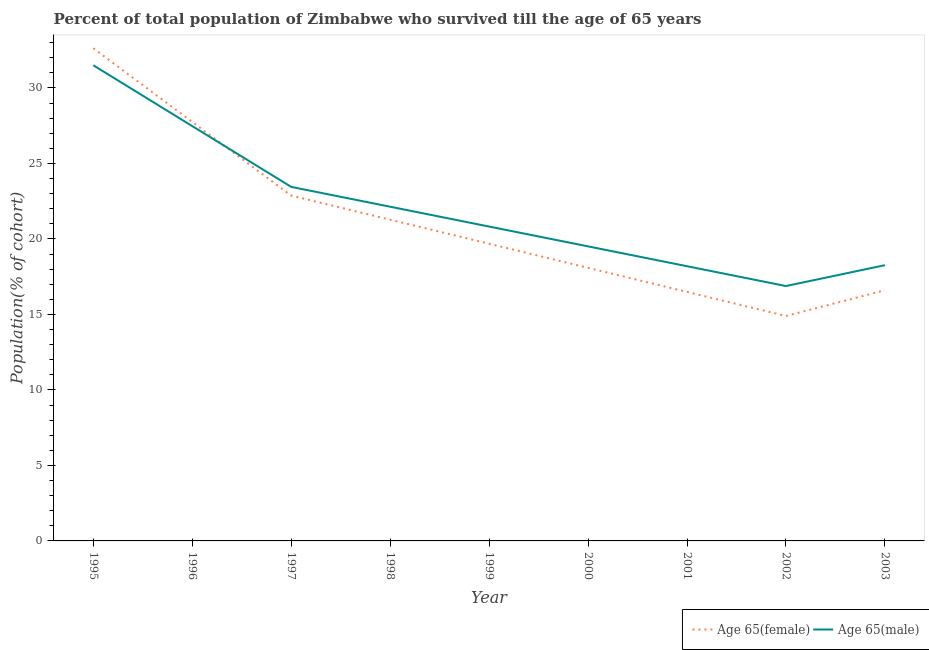How many different coloured lines are there?
Keep it short and to the point. 2. Does the line corresponding to percentage of female population who survived till age of 65 intersect with the line corresponding to percentage of male population who survived till age of 65?
Offer a very short reply. Yes. What is the percentage of female population who survived till age of 65 in 2002?
Your response must be concise. 14.9. Across all years, what is the maximum percentage of male population who survived till age of 65?
Offer a very short reply. 31.5. Across all years, what is the minimum percentage of male population who survived till age of 65?
Ensure brevity in your answer.  16.88. In which year was the percentage of female population who survived till age of 65 maximum?
Keep it short and to the point. 1995. In which year was the percentage of female population who survived till age of 65 minimum?
Your answer should be compact. 2002. What is the total percentage of male population who survived till age of 65 in the graph?
Provide a short and direct response. 198.22. What is the difference between the percentage of male population who survived till age of 65 in 1998 and that in 2001?
Offer a terse response. 3.94. What is the difference between the percentage of male population who survived till age of 65 in 1997 and the percentage of female population who survived till age of 65 in 1998?
Your response must be concise. 2.17. What is the average percentage of male population who survived till age of 65 per year?
Make the answer very short. 22.02. In the year 1998, what is the difference between the percentage of female population who survived till age of 65 and percentage of male population who survived till age of 65?
Your answer should be very brief. -0.86. What is the ratio of the percentage of female population who survived till age of 65 in 1996 to that in 2003?
Your response must be concise. 1.67. Is the percentage of male population who survived till age of 65 in 1995 less than that in 2000?
Offer a very short reply. No. Is the difference between the percentage of female population who survived till age of 65 in 1995 and 1997 greater than the difference between the percentage of male population who survived till age of 65 in 1995 and 1997?
Make the answer very short. Yes. What is the difference between the highest and the second highest percentage of female population who survived till age of 65?
Keep it short and to the point. 4.88. What is the difference between the highest and the lowest percentage of female population who survived till age of 65?
Give a very brief answer. 17.73. What is the difference between two consecutive major ticks on the Y-axis?
Provide a succinct answer. 5. Are the values on the major ticks of Y-axis written in scientific E-notation?
Offer a very short reply. No. Does the graph contain any zero values?
Provide a short and direct response. No. How many legend labels are there?
Give a very brief answer. 2. How are the legend labels stacked?
Your answer should be compact. Horizontal. What is the title of the graph?
Make the answer very short. Percent of total population of Zimbabwe who survived till the age of 65 years. What is the label or title of the Y-axis?
Provide a short and direct response. Population(% of cohort). What is the Population(% of cohort) of Age 65(female) in 1995?
Ensure brevity in your answer.  32.63. What is the Population(% of cohort) in Age 65(male) in 1995?
Provide a short and direct response. 31.5. What is the Population(% of cohort) of Age 65(female) in 1996?
Your response must be concise. 27.75. What is the Population(% of cohort) in Age 65(male) in 1996?
Ensure brevity in your answer.  27.47. What is the Population(% of cohort) in Age 65(female) in 1997?
Keep it short and to the point. 22.87. What is the Population(% of cohort) of Age 65(male) in 1997?
Offer a very short reply. 23.45. What is the Population(% of cohort) in Age 65(female) in 1998?
Provide a short and direct response. 21.28. What is the Population(% of cohort) of Age 65(male) in 1998?
Offer a terse response. 22.13. What is the Population(% of cohort) of Age 65(female) in 1999?
Provide a succinct answer. 19.68. What is the Population(% of cohort) of Age 65(male) in 1999?
Your answer should be very brief. 20.82. What is the Population(% of cohort) of Age 65(female) in 2000?
Give a very brief answer. 18.09. What is the Population(% of cohort) of Age 65(male) in 2000?
Your answer should be compact. 19.51. What is the Population(% of cohort) of Age 65(female) in 2001?
Make the answer very short. 16.49. What is the Population(% of cohort) of Age 65(male) in 2001?
Ensure brevity in your answer.  18.19. What is the Population(% of cohort) of Age 65(female) in 2002?
Your response must be concise. 14.9. What is the Population(% of cohort) in Age 65(male) in 2002?
Ensure brevity in your answer.  16.88. What is the Population(% of cohort) of Age 65(female) in 2003?
Offer a very short reply. 16.6. What is the Population(% of cohort) in Age 65(male) in 2003?
Make the answer very short. 18.26. Across all years, what is the maximum Population(% of cohort) in Age 65(female)?
Keep it short and to the point. 32.63. Across all years, what is the maximum Population(% of cohort) of Age 65(male)?
Provide a short and direct response. 31.5. Across all years, what is the minimum Population(% of cohort) of Age 65(female)?
Your response must be concise. 14.9. Across all years, what is the minimum Population(% of cohort) of Age 65(male)?
Your response must be concise. 16.88. What is the total Population(% of cohort) in Age 65(female) in the graph?
Your answer should be compact. 190.28. What is the total Population(% of cohort) in Age 65(male) in the graph?
Your answer should be very brief. 198.22. What is the difference between the Population(% of cohort) of Age 65(female) in 1995 and that in 1996?
Offer a very short reply. 4.88. What is the difference between the Population(% of cohort) in Age 65(male) in 1995 and that in 1996?
Make the answer very short. 4.03. What is the difference between the Population(% of cohort) of Age 65(female) in 1995 and that in 1997?
Your answer should be very brief. 9.76. What is the difference between the Population(% of cohort) in Age 65(male) in 1995 and that in 1997?
Make the answer very short. 8.05. What is the difference between the Population(% of cohort) in Age 65(female) in 1995 and that in 1998?
Give a very brief answer. 11.35. What is the difference between the Population(% of cohort) in Age 65(male) in 1995 and that in 1998?
Give a very brief answer. 9.37. What is the difference between the Population(% of cohort) of Age 65(female) in 1995 and that in 1999?
Offer a very short reply. 12.95. What is the difference between the Population(% of cohort) in Age 65(male) in 1995 and that in 1999?
Make the answer very short. 10.68. What is the difference between the Population(% of cohort) in Age 65(female) in 1995 and that in 2000?
Offer a terse response. 14.54. What is the difference between the Population(% of cohort) of Age 65(male) in 1995 and that in 2000?
Your answer should be compact. 11.99. What is the difference between the Population(% of cohort) of Age 65(female) in 1995 and that in 2001?
Provide a short and direct response. 16.14. What is the difference between the Population(% of cohort) of Age 65(male) in 1995 and that in 2001?
Provide a succinct answer. 13.31. What is the difference between the Population(% of cohort) of Age 65(female) in 1995 and that in 2002?
Offer a terse response. 17.73. What is the difference between the Population(% of cohort) of Age 65(male) in 1995 and that in 2002?
Provide a short and direct response. 14.62. What is the difference between the Population(% of cohort) of Age 65(female) in 1995 and that in 2003?
Give a very brief answer. 16.03. What is the difference between the Population(% of cohort) of Age 65(male) in 1995 and that in 2003?
Give a very brief answer. 13.24. What is the difference between the Population(% of cohort) in Age 65(female) in 1996 and that in 1997?
Give a very brief answer. 4.88. What is the difference between the Population(% of cohort) of Age 65(male) in 1996 and that in 1997?
Keep it short and to the point. 4.03. What is the difference between the Population(% of cohort) of Age 65(female) in 1996 and that in 1998?
Your answer should be very brief. 6.47. What is the difference between the Population(% of cohort) of Age 65(male) in 1996 and that in 1998?
Your answer should be compact. 5.34. What is the difference between the Population(% of cohort) of Age 65(female) in 1996 and that in 1999?
Provide a succinct answer. 8.07. What is the difference between the Population(% of cohort) in Age 65(male) in 1996 and that in 1999?
Ensure brevity in your answer.  6.65. What is the difference between the Population(% of cohort) in Age 65(female) in 1996 and that in 2000?
Provide a succinct answer. 9.66. What is the difference between the Population(% of cohort) of Age 65(male) in 1996 and that in 2000?
Offer a terse response. 7.97. What is the difference between the Population(% of cohort) in Age 65(female) in 1996 and that in 2001?
Keep it short and to the point. 11.26. What is the difference between the Population(% of cohort) in Age 65(male) in 1996 and that in 2001?
Give a very brief answer. 9.28. What is the difference between the Population(% of cohort) in Age 65(female) in 1996 and that in 2002?
Offer a very short reply. 12.85. What is the difference between the Population(% of cohort) in Age 65(male) in 1996 and that in 2002?
Give a very brief answer. 10.59. What is the difference between the Population(% of cohort) of Age 65(female) in 1996 and that in 2003?
Offer a terse response. 11.15. What is the difference between the Population(% of cohort) in Age 65(male) in 1996 and that in 2003?
Your answer should be very brief. 9.21. What is the difference between the Population(% of cohort) in Age 65(female) in 1997 and that in 1998?
Your response must be concise. 1.59. What is the difference between the Population(% of cohort) of Age 65(male) in 1997 and that in 1998?
Your answer should be compact. 1.31. What is the difference between the Population(% of cohort) in Age 65(female) in 1997 and that in 1999?
Keep it short and to the point. 3.19. What is the difference between the Population(% of cohort) in Age 65(male) in 1997 and that in 1999?
Offer a terse response. 2.63. What is the difference between the Population(% of cohort) in Age 65(female) in 1997 and that in 2000?
Your response must be concise. 4.78. What is the difference between the Population(% of cohort) in Age 65(male) in 1997 and that in 2000?
Make the answer very short. 3.94. What is the difference between the Population(% of cohort) in Age 65(female) in 1997 and that in 2001?
Offer a very short reply. 6.38. What is the difference between the Population(% of cohort) of Age 65(male) in 1997 and that in 2001?
Provide a short and direct response. 5.25. What is the difference between the Population(% of cohort) in Age 65(female) in 1997 and that in 2002?
Ensure brevity in your answer.  7.97. What is the difference between the Population(% of cohort) of Age 65(male) in 1997 and that in 2002?
Your answer should be compact. 6.57. What is the difference between the Population(% of cohort) of Age 65(female) in 1997 and that in 2003?
Offer a very short reply. 6.27. What is the difference between the Population(% of cohort) of Age 65(male) in 1997 and that in 2003?
Offer a terse response. 5.19. What is the difference between the Population(% of cohort) in Age 65(female) in 1998 and that in 1999?
Make the answer very short. 1.59. What is the difference between the Population(% of cohort) in Age 65(male) in 1998 and that in 1999?
Keep it short and to the point. 1.31. What is the difference between the Population(% of cohort) of Age 65(female) in 1998 and that in 2000?
Keep it short and to the point. 3.19. What is the difference between the Population(% of cohort) in Age 65(male) in 1998 and that in 2000?
Your answer should be compact. 2.63. What is the difference between the Population(% of cohort) in Age 65(female) in 1998 and that in 2001?
Provide a succinct answer. 4.78. What is the difference between the Population(% of cohort) of Age 65(male) in 1998 and that in 2001?
Provide a short and direct response. 3.94. What is the difference between the Population(% of cohort) in Age 65(female) in 1998 and that in 2002?
Give a very brief answer. 6.38. What is the difference between the Population(% of cohort) of Age 65(male) in 1998 and that in 2002?
Your answer should be very brief. 5.25. What is the difference between the Population(% of cohort) in Age 65(female) in 1998 and that in 2003?
Provide a short and direct response. 4.67. What is the difference between the Population(% of cohort) of Age 65(male) in 1998 and that in 2003?
Give a very brief answer. 3.87. What is the difference between the Population(% of cohort) in Age 65(female) in 1999 and that in 2000?
Make the answer very short. 1.59. What is the difference between the Population(% of cohort) in Age 65(male) in 1999 and that in 2000?
Provide a short and direct response. 1.31. What is the difference between the Population(% of cohort) of Age 65(female) in 1999 and that in 2001?
Offer a terse response. 3.19. What is the difference between the Population(% of cohort) in Age 65(male) in 1999 and that in 2001?
Ensure brevity in your answer.  2.63. What is the difference between the Population(% of cohort) of Age 65(female) in 1999 and that in 2002?
Offer a very short reply. 4.78. What is the difference between the Population(% of cohort) in Age 65(male) in 1999 and that in 2002?
Your answer should be compact. 3.94. What is the difference between the Population(% of cohort) of Age 65(female) in 1999 and that in 2003?
Your answer should be very brief. 3.08. What is the difference between the Population(% of cohort) of Age 65(male) in 1999 and that in 2003?
Provide a succinct answer. 2.56. What is the difference between the Population(% of cohort) in Age 65(female) in 2000 and that in 2001?
Provide a short and direct response. 1.59. What is the difference between the Population(% of cohort) of Age 65(male) in 2000 and that in 2001?
Your response must be concise. 1.31. What is the difference between the Population(% of cohort) in Age 65(female) in 2000 and that in 2002?
Your answer should be compact. 3.19. What is the difference between the Population(% of cohort) in Age 65(male) in 2000 and that in 2002?
Provide a short and direct response. 2.63. What is the difference between the Population(% of cohort) in Age 65(female) in 2000 and that in 2003?
Give a very brief answer. 1.49. What is the difference between the Population(% of cohort) of Age 65(male) in 2000 and that in 2003?
Provide a succinct answer. 1.25. What is the difference between the Population(% of cohort) in Age 65(female) in 2001 and that in 2002?
Provide a succinct answer. 1.59. What is the difference between the Population(% of cohort) in Age 65(male) in 2001 and that in 2002?
Offer a very short reply. 1.31. What is the difference between the Population(% of cohort) of Age 65(female) in 2001 and that in 2003?
Your answer should be very brief. -0.11. What is the difference between the Population(% of cohort) in Age 65(male) in 2001 and that in 2003?
Your answer should be very brief. -0.07. What is the difference between the Population(% of cohort) of Age 65(female) in 2002 and that in 2003?
Offer a terse response. -1.7. What is the difference between the Population(% of cohort) of Age 65(male) in 2002 and that in 2003?
Ensure brevity in your answer.  -1.38. What is the difference between the Population(% of cohort) of Age 65(female) in 1995 and the Population(% of cohort) of Age 65(male) in 1996?
Provide a succinct answer. 5.15. What is the difference between the Population(% of cohort) of Age 65(female) in 1995 and the Population(% of cohort) of Age 65(male) in 1997?
Your answer should be very brief. 9.18. What is the difference between the Population(% of cohort) of Age 65(female) in 1995 and the Population(% of cohort) of Age 65(male) in 1998?
Your response must be concise. 10.49. What is the difference between the Population(% of cohort) in Age 65(female) in 1995 and the Population(% of cohort) in Age 65(male) in 1999?
Offer a very short reply. 11.81. What is the difference between the Population(% of cohort) in Age 65(female) in 1995 and the Population(% of cohort) in Age 65(male) in 2000?
Give a very brief answer. 13.12. What is the difference between the Population(% of cohort) of Age 65(female) in 1995 and the Population(% of cohort) of Age 65(male) in 2001?
Your answer should be compact. 14.43. What is the difference between the Population(% of cohort) of Age 65(female) in 1995 and the Population(% of cohort) of Age 65(male) in 2002?
Provide a succinct answer. 15.75. What is the difference between the Population(% of cohort) in Age 65(female) in 1995 and the Population(% of cohort) in Age 65(male) in 2003?
Give a very brief answer. 14.37. What is the difference between the Population(% of cohort) in Age 65(female) in 1996 and the Population(% of cohort) in Age 65(male) in 1997?
Give a very brief answer. 4.3. What is the difference between the Population(% of cohort) in Age 65(female) in 1996 and the Population(% of cohort) in Age 65(male) in 1998?
Provide a short and direct response. 5.62. What is the difference between the Population(% of cohort) of Age 65(female) in 1996 and the Population(% of cohort) of Age 65(male) in 1999?
Your response must be concise. 6.93. What is the difference between the Population(% of cohort) of Age 65(female) in 1996 and the Population(% of cohort) of Age 65(male) in 2000?
Your response must be concise. 8.24. What is the difference between the Population(% of cohort) of Age 65(female) in 1996 and the Population(% of cohort) of Age 65(male) in 2001?
Give a very brief answer. 9.56. What is the difference between the Population(% of cohort) of Age 65(female) in 1996 and the Population(% of cohort) of Age 65(male) in 2002?
Offer a terse response. 10.87. What is the difference between the Population(% of cohort) of Age 65(female) in 1996 and the Population(% of cohort) of Age 65(male) in 2003?
Your answer should be compact. 9.49. What is the difference between the Population(% of cohort) in Age 65(female) in 1997 and the Population(% of cohort) in Age 65(male) in 1998?
Offer a very short reply. 0.74. What is the difference between the Population(% of cohort) in Age 65(female) in 1997 and the Population(% of cohort) in Age 65(male) in 1999?
Your response must be concise. 2.05. What is the difference between the Population(% of cohort) of Age 65(female) in 1997 and the Population(% of cohort) of Age 65(male) in 2000?
Provide a succinct answer. 3.36. What is the difference between the Population(% of cohort) of Age 65(female) in 1997 and the Population(% of cohort) of Age 65(male) in 2001?
Your answer should be very brief. 4.68. What is the difference between the Population(% of cohort) in Age 65(female) in 1997 and the Population(% of cohort) in Age 65(male) in 2002?
Offer a very short reply. 5.99. What is the difference between the Population(% of cohort) of Age 65(female) in 1997 and the Population(% of cohort) of Age 65(male) in 2003?
Provide a short and direct response. 4.61. What is the difference between the Population(% of cohort) in Age 65(female) in 1998 and the Population(% of cohort) in Age 65(male) in 1999?
Make the answer very short. 0.46. What is the difference between the Population(% of cohort) in Age 65(female) in 1998 and the Population(% of cohort) in Age 65(male) in 2000?
Your response must be concise. 1.77. What is the difference between the Population(% of cohort) of Age 65(female) in 1998 and the Population(% of cohort) of Age 65(male) in 2001?
Keep it short and to the point. 3.08. What is the difference between the Population(% of cohort) in Age 65(female) in 1998 and the Population(% of cohort) in Age 65(male) in 2002?
Provide a short and direct response. 4.4. What is the difference between the Population(% of cohort) of Age 65(female) in 1998 and the Population(% of cohort) of Age 65(male) in 2003?
Your answer should be compact. 3.01. What is the difference between the Population(% of cohort) in Age 65(female) in 1999 and the Population(% of cohort) in Age 65(male) in 2000?
Provide a succinct answer. 0.17. What is the difference between the Population(% of cohort) in Age 65(female) in 1999 and the Population(% of cohort) in Age 65(male) in 2001?
Your answer should be compact. 1.49. What is the difference between the Population(% of cohort) of Age 65(female) in 1999 and the Population(% of cohort) of Age 65(male) in 2002?
Ensure brevity in your answer.  2.8. What is the difference between the Population(% of cohort) in Age 65(female) in 1999 and the Population(% of cohort) in Age 65(male) in 2003?
Your answer should be compact. 1.42. What is the difference between the Population(% of cohort) of Age 65(female) in 2000 and the Population(% of cohort) of Age 65(male) in 2001?
Offer a terse response. -0.11. What is the difference between the Population(% of cohort) of Age 65(female) in 2000 and the Population(% of cohort) of Age 65(male) in 2002?
Provide a succinct answer. 1.21. What is the difference between the Population(% of cohort) of Age 65(female) in 2000 and the Population(% of cohort) of Age 65(male) in 2003?
Provide a succinct answer. -0.18. What is the difference between the Population(% of cohort) in Age 65(female) in 2001 and the Population(% of cohort) in Age 65(male) in 2002?
Your answer should be very brief. -0.39. What is the difference between the Population(% of cohort) in Age 65(female) in 2001 and the Population(% of cohort) in Age 65(male) in 2003?
Give a very brief answer. -1.77. What is the difference between the Population(% of cohort) in Age 65(female) in 2002 and the Population(% of cohort) in Age 65(male) in 2003?
Offer a very short reply. -3.36. What is the average Population(% of cohort) of Age 65(female) per year?
Your response must be concise. 21.14. What is the average Population(% of cohort) of Age 65(male) per year?
Offer a terse response. 22.02. In the year 1995, what is the difference between the Population(% of cohort) in Age 65(female) and Population(% of cohort) in Age 65(male)?
Your answer should be compact. 1.13. In the year 1996, what is the difference between the Population(% of cohort) of Age 65(female) and Population(% of cohort) of Age 65(male)?
Provide a succinct answer. 0.28. In the year 1997, what is the difference between the Population(% of cohort) of Age 65(female) and Population(% of cohort) of Age 65(male)?
Offer a very short reply. -0.58. In the year 1998, what is the difference between the Population(% of cohort) of Age 65(female) and Population(% of cohort) of Age 65(male)?
Your answer should be very brief. -0.86. In the year 1999, what is the difference between the Population(% of cohort) of Age 65(female) and Population(% of cohort) of Age 65(male)?
Make the answer very short. -1.14. In the year 2000, what is the difference between the Population(% of cohort) in Age 65(female) and Population(% of cohort) in Age 65(male)?
Offer a terse response. -1.42. In the year 2001, what is the difference between the Population(% of cohort) of Age 65(female) and Population(% of cohort) of Age 65(male)?
Ensure brevity in your answer.  -1.7. In the year 2002, what is the difference between the Population(% of cohort) in Age 65(female) and Population(% of cohort) in Age 65(male)?
Make the answer very short. -1.98. In the year 2003, what is the difference between the Population(% of cohort) in Age 65(female) and Population(% of cohort) in Age 65(male)?
Provide a succinct answer. -1.66. What is the ratio of the Population(% of cohort) of Age 65(female) in 1995 to that in 1996?
Give a very brief answer. 1.18. What is the ratio of the Population(% of cohort) of Age 65(male) in 1995 to that in 1996?
Provide a succinct answer. 1.15. What is the ratio of the Population(% of cohort) in Age 65(female) in 1995 to that in 1997?
Provide a short and direct response. 1.43. What is the ratio of the Population(% of cohort) of Age 65(male) in 1995 to that in 1997?
Give a very brief answer. 1.34. What is the ratio of the Population(% of cohort) in Age 65(female) in 1995 to that in 1998?
Your answer should be very brief. 1.53. What is the ratio of the Population(% of cohort) of Age 65(male) in 1995 to that in 1998?
Keep it short and to the point. 1.42. What is the ratio of the Population(% of cohort) of Age 65(female) in 1995 to that in 1999?
Give a very brief answer. 1.66. What is the ratio of the Population(% of cohort) of Age 65(male) in 1995 to that in 1999?
Keep it short and to the point. 1.51. What is the ratio of the Population(% of cohort) in Age 65(female) in 1995 to that in 2000?
Provide a short and direct response. 1.8. What is the ratio of the Population(% of cohort) in Age 65(male) in 1995 to that in 2000?
Your answer should be compact. 1.61. What is the ratio of the Population(% of cohort) in Age 65(female) in 1995 to that in 2001?
Ensure brevity in your answer.  1.98. What is the ratio of the Population(% of cohort) of Age 65(male) in 1995 to that in 2001?
Keep it short and to the point. 1.73. What is the ratio of the Population(% of cohort) in Age 65(female) in 1995 to that in 2002?
Offer a very short reply. 2.19. What is the ratio of the Population(% of cohort) in Age 65(male) in 1995 to that in 2002?
Offer a very short reply. 1.87. What is the ratio of the Population(% of cohort) of Age 65(female) in 1995 to that in 2003?
Provide a short and direct response. 1.97. What is the ratio of the Population(% of cohort) in Age 65(male) in 1995 to that in 2003?
Ensure brevity in your answer.  1.73. What is the ratio of the Population(% of cohort) of Age 65(female) in 1996 to that in 1997?
Offer a terse response. 1.21. What is the ratio of the Population(% of cohort) in Age 65(male) in 1996 to that in 1997?
Ensure brevity in your answer.  1.17. What is the ratio of the Population(% of cohort) in Age 65(female) in 1996 to that in 1998?
Provide a succinct answer. 1.3. What is the ratio of the Population(% of cohort) of Age 65(male) in 1996 to that in 1998?
Your response must be concise. 1.24. What is the ratio of the Population(% of cohort) of Age 65(female) in 1996 to that in 1999?
Give a very brief answer. 1.41. What is the ratio of the Population(% of cohort) of Age 65(male) in 1996 to that in 1999?
Provide a succinct answer. 1.32. What is the ratio of the Population(% of cohort) of Age 65(female) in 1996 to that in 2000?
Offer a terse response. 1.53. What is the ratio of the Population(% of cohort) of Age 65(male) in 1996 to that in 2000?
Give a very brief answer. 1.41. What is the ratio of the Population(% of cohort) of Age 65(female) in 1996 to that in 2001?
Give a very brief answer. 1.68. What is the ratio of the Population(% of cohort) of Age 65(male) in 1996 to that in 2001?
Your answer should be very brief. 1.51. What is the ratio of the Population(% of cohort) of Age 65(female) in 1996 to that in 2002?
Provide a short and direct response. 1.86. What is the ratio of the Population(% of cohort) in Age 65(male) in 1996 to that in 2002?
Make the answer very short. 1.63. What is the ratio of the Population(% of cohort) of Age 65(female) in 1996 to that in 2003?
Offer a very short reply. 1.67. What is the ratio of the Population(% of cohort) of Age 65(male) in 1996 to that in 2003?
Offer a terse response. 1.5. What is the ratio of the Population(% of cohort) of Age 65(female) in 1997 to that in 1998?
Provide a short and direct response. 1.07. What is the ratio of the Population(% of cohort) of Age 65(male) in 1997 to that in 1998?
Provide a short and direct response. 1.06. What is the ratio of the Population(% of cohort) in Age 65(female) in 1997 to that in 1999?
Your response must be concise. 1.16. What is the ratio of the Population(% of cohort) in Age 65(male) in 1997 to that in 1999?
Your answer should be compact. 1.13. What is the ratio of the Population(% of cohort) of Age 65(female) in 1997 to that in 2000?
Your response must be concise. 1.26. What is the ratio of the Population(% of cohort) of Age 65(male) in 1997 to that in 2000?
Ensure brevity in your answer.  1.2. What is the ratio of the Population(% of cohort) of Age 65(female) in 1997 to that in 2001?
Keep it short and to the point. 1.39. What is the ratio of the Population(% of cohort) in Age 65(male) in 1997 to that in 2001?
Provide a short and direct response. 1.29. What is the ratio of the Population(% of cohort) in Age 65(female) in 1997 to that in 2002?
Your response must be concise. 1.54. What is the ratio of the Population(% of cohort) in Age 65(male) in 1997 to that in 2002?
Make the answer very short. 1.39. What is the ratio of the Population(% of cohort) in Age 65(female) in 1997 to that in 2003?
Make the answer very short. 1.38. What is the ratio of the Population(% of cohort) in Age 65(male) in 1997 to that in 2003?
Give a very brief answer. 1.28. What is the ratio of the Population(% of cohort) in Age 65(female) in 1998 to that in 1999?
Provide a short and direct response. 1.08. What is the ratio of the Population(% of cohort) in Age 65(male) in 1998 to that in 1999?
Offer a terse response. 1.06. What is the ratio of the Population(% of cohort) of Age 65(female) in 1998 to that in 2000?
Offer a terse response. 1.18. What is the ratio of the Population(% of cohort) in Age 65(male) in 1998 to that in 2000?
Offer a very short reply. 1.13. What is the ratio of the Population(% of cohort) of Age 65(female) in 1998 to that in 2001?
Ensure brevity in your answer.  1.29. What is the ratio of the Population(% of cohort) in Age 65(male) in 1998 to that in 2001?
Ensure brevity in your answer.  1.22. What is the ratio of the Population(% of cohort) in Age 65(female) in 1998 to that in 2002?
Ensure brevity in your answer.  1.43. What is the ratio of the Population(% of cohort) of Age 65(male) in 1998 to that in 2002?
Offer a terse response. 1.31. What is the ratio of the Population(% of cohort) in Age 65(female) in 1998 to that in 2003?
Offer a terse response. 1.28. What is the ratio of the Population(% of cohort) of Age 65(male) in 1998 to that in 2003?
Your answer should be compact. 1.21. What is the ratio of the Population(% of cohort) in Age 65(female) in 1999 to that in 2000?
Offer a very short reply. 1.09. What is the ratio of the Population(% of cohort) in Age 65(male) in 1999 to that in 2000?
Keep it short and to the point. 1.07. What is the ratio of the Population(% of cohort) of Age 65(female) in 1999 to that in 2001?
Your answer should be compact. 1.19. What is the ratio of the Population(% of cohort) in Age 65(male) in 1999 to that in 2001?
Give a very brief answer. 1.14. What is the ratio of the Population(% of cohort) of Age 65(female) in 1999 to that in 2002?
Provide a short and direct response. 1.32. What is the ratio of the Population(% of cohort) in Age 65(male) in 1999 to that in 2002?
Offer a very short reply. 1.23. What is the ratio of the Population(% of cohort) of Age 65(female) in 1999 to that in 2003?
Provide a succinct answer. 1.19. What is the ratio of the Population(% of cohort) of Age 65(male) in 1999 to that in 2003?
Your answer should be very brief. 1.14. What is the ratio of the Population(% of cohort) of Age 65(female) in 2000 to that in 2001?
Give a very brief answer. 1.1. What is the ratio of the Population(% of cohort) in Age 65(male) in 2000 to that in 2001?
Your response must be concise. 1.07. What is the ratio of the Population(% of cohort) of Age 65(female) in 2000 to that in 2002?
Your response must be concise. 1.21. What is the ratio of the Population(% of cohort) of Age 65(male) in 2000 to that in 2002?
Provide a short and direct response. 1.16. What is the ratio of the Population(% of cohort) in Age 65(female) in 2000 to that in 2003?
Provide a succinct answer. 1.09. What is the ratio of the Population(% of cohort) of Age 65(male) in 2000 to that in 2003?
Provide a succinct answer. 1.07. What is the ratio of the Population(% of cohort) of Age 65(female) in 2001 to that in 2002?
Ensure brevity in your answer.  1.11. What is the ratio of the Population(% of cohort) in Age 65(male) in 2001 to that in 2002?
Offer a terse response. 1.08. What is the ratio of the Population(% of cohort) of Age 65(female) in 2002 to that in 2003?
Ensure brevity in your answer.  0.9. What is the ratio of the Population(% of cohort) in Age 65(male) in 2002 to that in 2003?
Your answer should be very brief. 0.92. What is the difference between the highest and the second highest Population(% of cohort) in Age 65(female)?
Give a very brief answer. 4.88. What is the difference between the highest and the second highest Population(% of cohort) of Age 65(male)?
Provide a short and direct response. 4.03. What is the difference between the highest and the lowest Population(% of cohort) in Age 65(female)?
Your response must be concise. 17.73. What is the difference between the highest and the lowest Population(% of cohort) of Age 65(male)?
Offer a terse response. 14.62. 